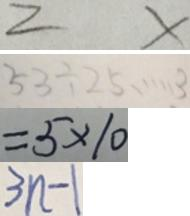<formula> <loc_0><loc_0><loc_500><loc_500>2 x 
 5 3 \div 2 5 \cdots 3 
 = 5 \times 1 0 
 3 n - 1</formula> 